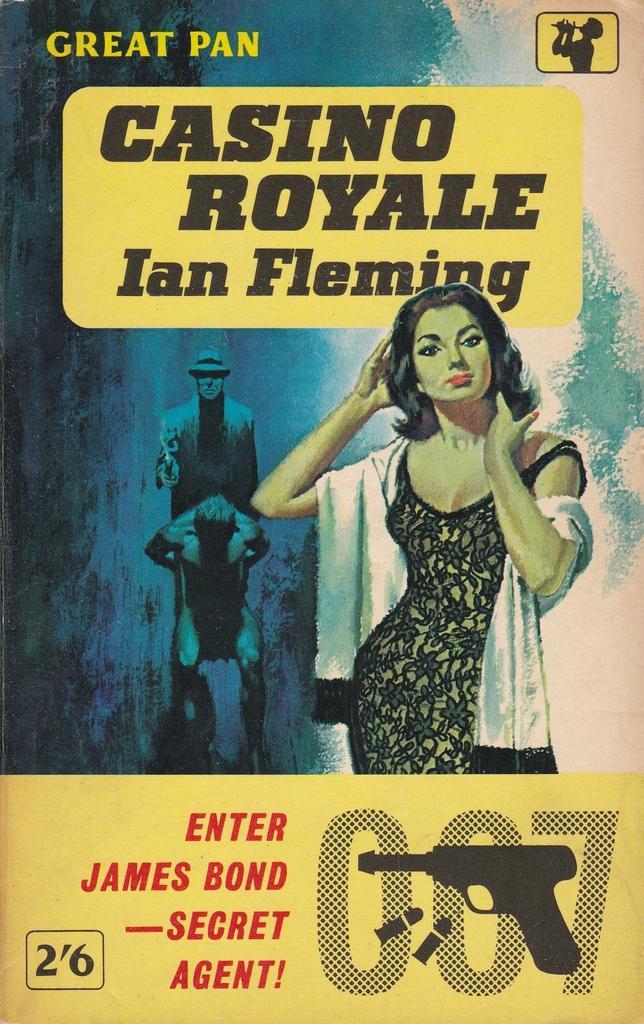In one or two sentences, can you explain what this image depicts? Here we can see a poster. On this poster we can see picture of a woman, two persons, gun, bullets, and text written on it. 